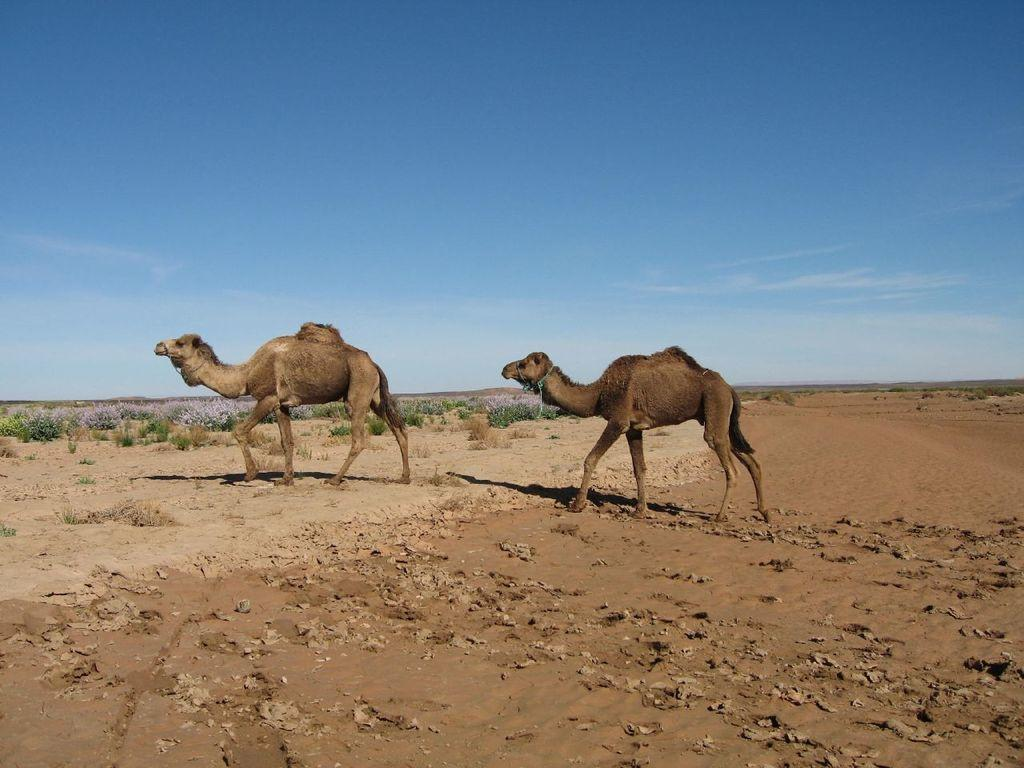What animals can be seen in the image? There are two camels in the image. What is the camels doing in the image? The camels are walking on the sand. What type of terrain is visible in the image? There is soil on the floor. What can be seen in the background of the image? There are plants in the background of the image. What is the condition of the sky in the image? The sky is clear in the image. What type of drug is being administered to the camels in the image? There is no indication in the image that the camels are receiving any drugs, so it cannot be determined from the picture. 